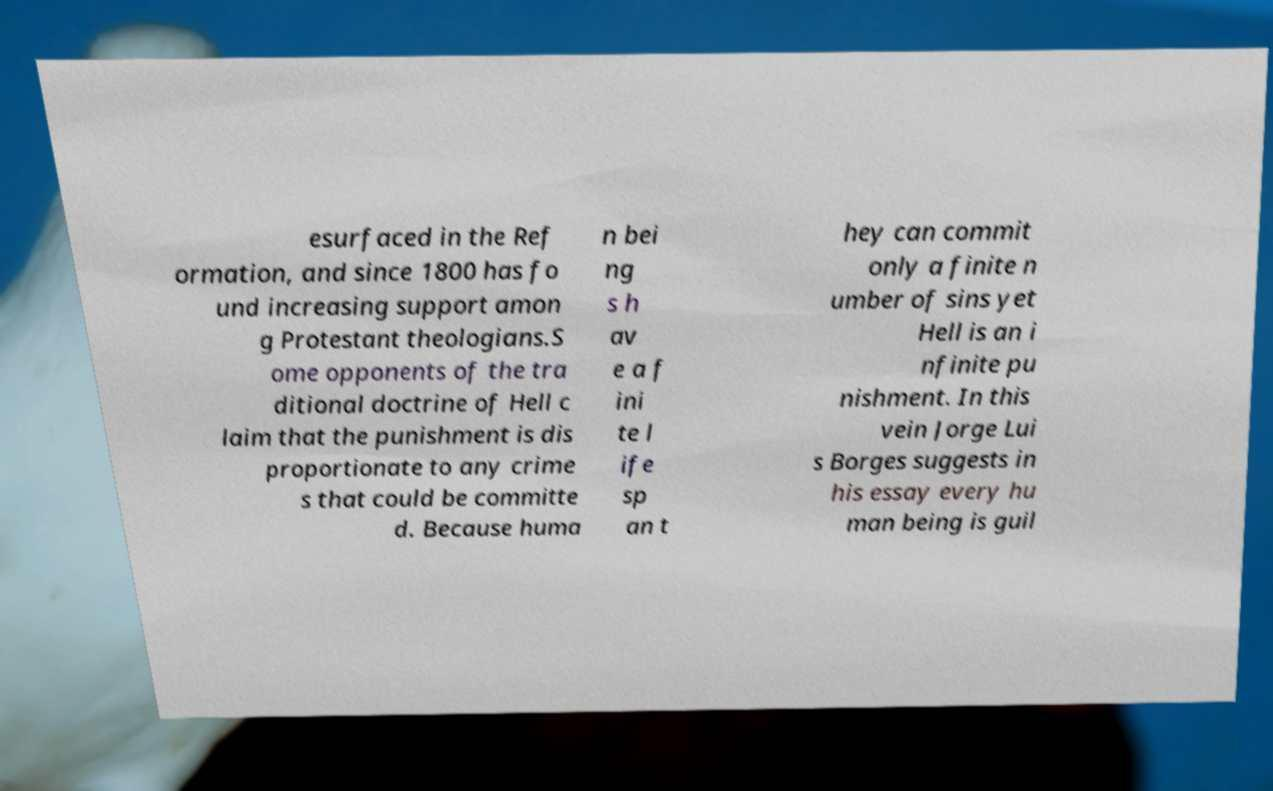Could you assist in decoding the text presented in this image and type it out clearly? esurfaced in the Ref ormation, and since 1800 has fo und increasing support amon g Protestant theologians.S ome opponents of the tra ditional doctrine of Hell c laim that the punishment is dis proportionate to any crime s that could be committe d. Because huma n bei ng s h av e a f ini te l ife sp an t hey can commit only a finite n umber of sins yet Hell is an i nfinite pu nishment. In this vein Jorge Lui s Borges suggests in his essay every hu man being is guil 